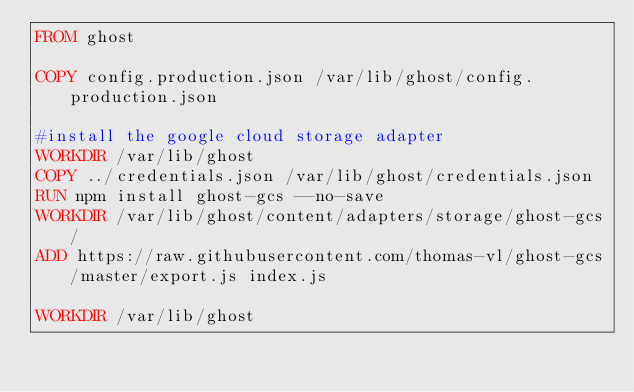Convert code to text. <code><loc_0><loc_0><loc_500><loc_500><_Dockerfile_>FROM ghost

COPY config.production.json /var/lib/ghost/config.production.json

#install the google cloud storage adapter
WORKDIR /var/lib/ghost
COPY ../credentials.json /var/lib/ghost/credentials.json
RUN npm install ghost-gcs --no-save 
WORKDIR /var/lib/ghost/content/adapters/storage/ghost-gcs/
ADD https://raw.githubusercontent.com/thomas-vl/ghost-gcs/master/export.js index.js

WORKDIR /var/lib/ghost</code> 